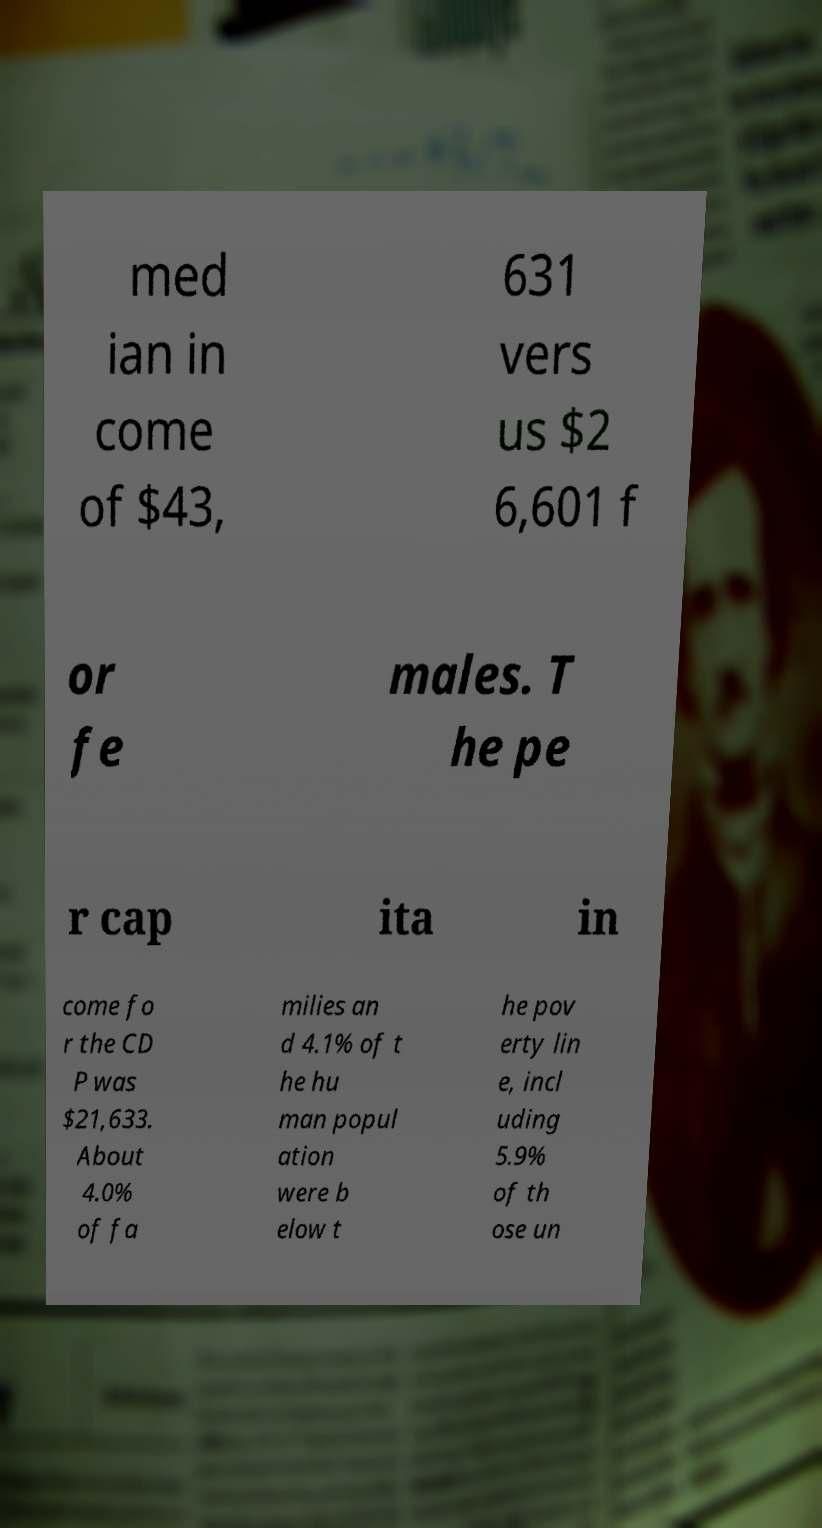I need the written content from this picture converted into text. Can you do that? med ian in come of $43, 631 vers us $2 6,601 f or fe males. T he pe r cap ita in come fo r the CD P was $21,633. About 4.0% of fa milies an d 4.1% of t he hu man popul ation were b elow t he pov erty lin e, incl uding 5.9% of th ose un 